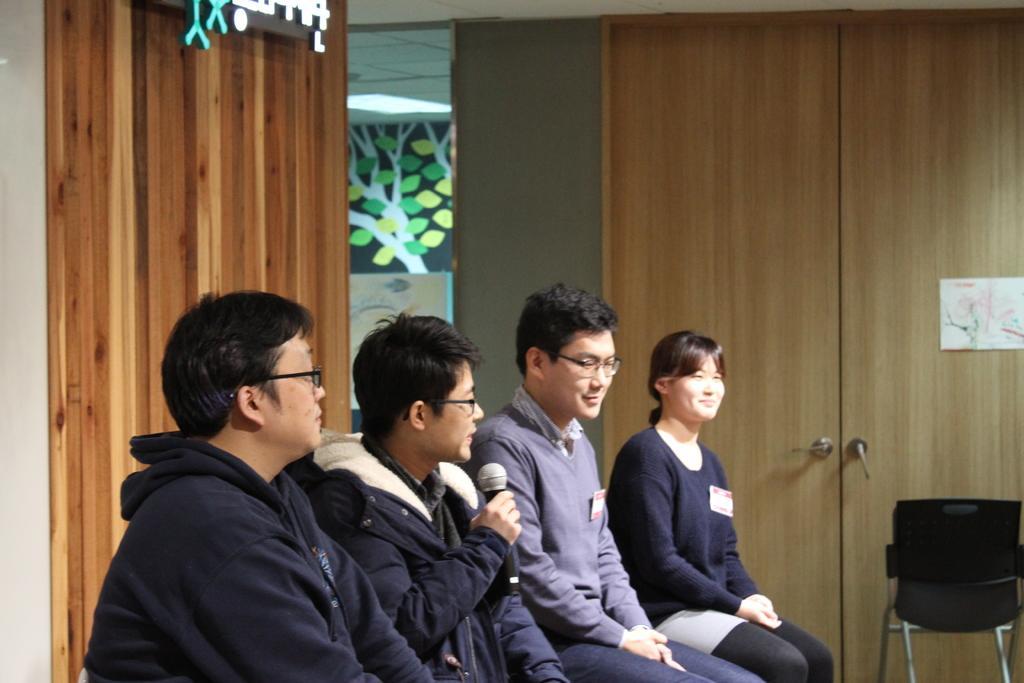Please provide a concise description of this image. A group of three men and a woman are sitting. In which a men is speaking with a mic in his hand and the rest are listening to him. 